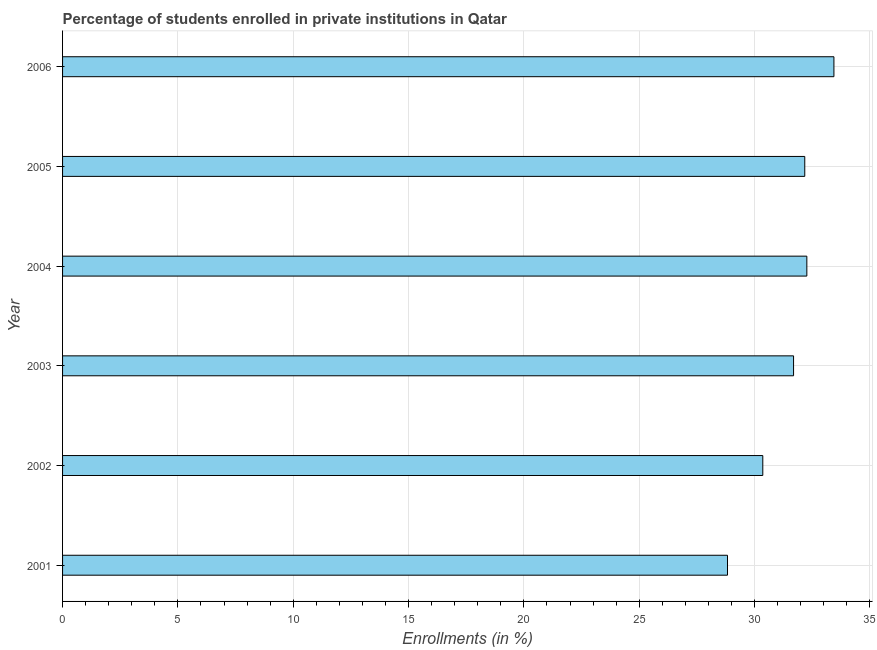Does the graph contain any zero values?
Ensure brevity in your answer.  No. Does the graph contain grids?
Provide a succinct answer. Yes. What is the title of the graph?
Make the answer very short. Percentage of students enrolled in private institutions in Qatar. What is the label or title of the X-axis?
Your response must be concise. Enrollments (in %). What is the label or title of the Y-axis?
Offer a terse response. Year. What is the enrollments in private institutions in 2001?
Keep it short and to the point. 28.83. Across all years, what is the maximum enrollments in private institutions?
Offer a terse response. 33.44. Across all years, what is the minimum enrollments in private institutions?
Give a very brief answer. 28.83. In which year was the enrollments in private institutions maximum?
Ensure brevity in your answer.  2006. In which year was the enrollments in private institutions minimum?
Provide a short and direct response. 2001. What is the sum of the enrollments in private institutions?
Your answer should be compact. 188.76. What is the difference between the enrollments in private institutions in 2004 and 2006?
Offer a terse response. -1.17. What is the average enrollments in private institutions per year?
Your response must be concise. 31.46. What is the median enrollments in private institutions?
Offer a terse response. 31.93. In how many years, is the enrollments in private institutions greater than 28 %?
Make the answer very short. 6. Do a majority of the years between 2004 and 2005 (inclusive) have enrollments in private institutions greater than 6 %?
Offer a very short reply. Yes. What is the ratio of the enrollments in private institutions in 2002 to that in 2006?
Offer a very short reply. 0.91. Is the enrollments in private institutions in 2002 less than that in 2006?
Offer a terse response. Yes. What is the difference between the highest and the second highest enrollments in private institutions?
Your answer should be compact. 1.17. What is the difference between the highest and the lowest enrollments in private institutions?
Keep it short and to the point. 4.61. How many bars are there?
Keep it short and to the point. 6. Are all the bars in the graph horizontal?
Make the answer very short. Yes. How many years are there in the graph?
Provide a short and direct response. 6. What is the difference between two consecutive major ticks on the X-axis?
Your answer should be compact. 5. Are the values on the major ticks of X-axis written in scientific E-notation?
Provide a succinct answer. No. What is the Enrollments (in %) of 2001?
Provide a succinct answer. 28.83. What is the Enrollments (in %) of 2002?
Your answer should be compact. 30.36. What is the Enrollments (in %) in 2003?
Offer a terse response. 31.69. What is the Enrollments (in %) of 2004?
Offer a very short reply. 32.27. What is the Enrollments (in %) of 2005?
Offer a terse response. 32.18. What is the Enrollments (in %) in 2006?
Provide a succinct answer. 33.44. What is the difference between the Enrollments (in %) in 2001 and 2002?
Your answer should be very brief. -1.53. What is the difference between the Enrollments (in %) in 2001 and 2003?
Your answer should be compact. -2.86. What is the difference between the Enrollments (in %) in 2001 and 2004?
Your response must be concise. -3.44. What is the difference between the Enrollments (in %) in 2001 and 2005?
Your answer should be very brief. -3.35. What is the difference between the Enrollments (in %) in 2001 and 2006?
Offer a very short reply. -4.61. What is the difference between the Enrollments (in %) in 2002 and 2003?
Your answer should be very brief. -1.33. What is the difference between the Enrollments (in %) in 2002 and 2004?
Your answer should be very brief. -1.91. What is the difference between the Enrollments (in %) in 2002 and 2005?
Make the answer very short. -1.82. What is the difference between the Enrollments (in %) in 2002 and 2006?
Keep it short and to the point. -3.08. What is the difference between the Enrollments (in %) in 2003 and 2004?
Your response must be concise. -0.58. What is the difference between the Enrollments (in %) in 2003 and 2005?
Ensure brevity in your answer.  -0.49. What is the difference between the Enrollments (in %) in 2003 and 2006?
Give a very brief answer. -1.75. What is the difference between the Enrollments (in %) in 2004 and 2005?
Ensure brevity in your answer.  0.09. What is the difference between the Enrollments (in %) in 2004 and 2006?
Your answer should be compact. -1.17. What is the difference between the Enrollments (in %) in 2005 and 2006?
Your answer should be very brief. -1.26. What is the ratio of the Enrollments (in %) in 2001 to that in 2002?
Offer a very short reply. 0.95. What is the ratio of the Enrollments (in %) in 2001 to that in 2003?
Provide a short and direct response. 0.91. What is the ratio of the Enrollments (in %) in 2001 to that in 2004?
Your response must be concise. 0.89. What is the ratio of the Enrollments (in %) in 2001 to that in 2005?
Keep it short and to the point. 0.9. What is the ratio of the Enrollments (in %) in 2001 to that in 2006?
Keep it short and to the point. 0.86. What is the ratio of the Enrollments (in %) in 2002 to that in 2003?
Your response must be concise. 0.96. What is the ratio of the Enrollments (in %) in 2002 to that in 2004?
Give a very brief answer. 0.94. What is the ratio of the Enrollments (in %) in 2002 to that in 2005?
Your answer should be very brief. 0.94. What is the ratio of the Enrollments (in %) in 2002 to that in 2006?
Provide a short and direct response. 0.91. What is the ratio of the Enrollments (in %) in 2003 to that in 2005?
Your answer should be very brief. 0.98. What is the ratio of the Enrollments (in %) in 2003 to that in 2006?
Offer a very short reply. 0.95. What is the ratio of the Enrollments (in %) in 2004 to that in 2005?
Offer a very short reply. 1. 